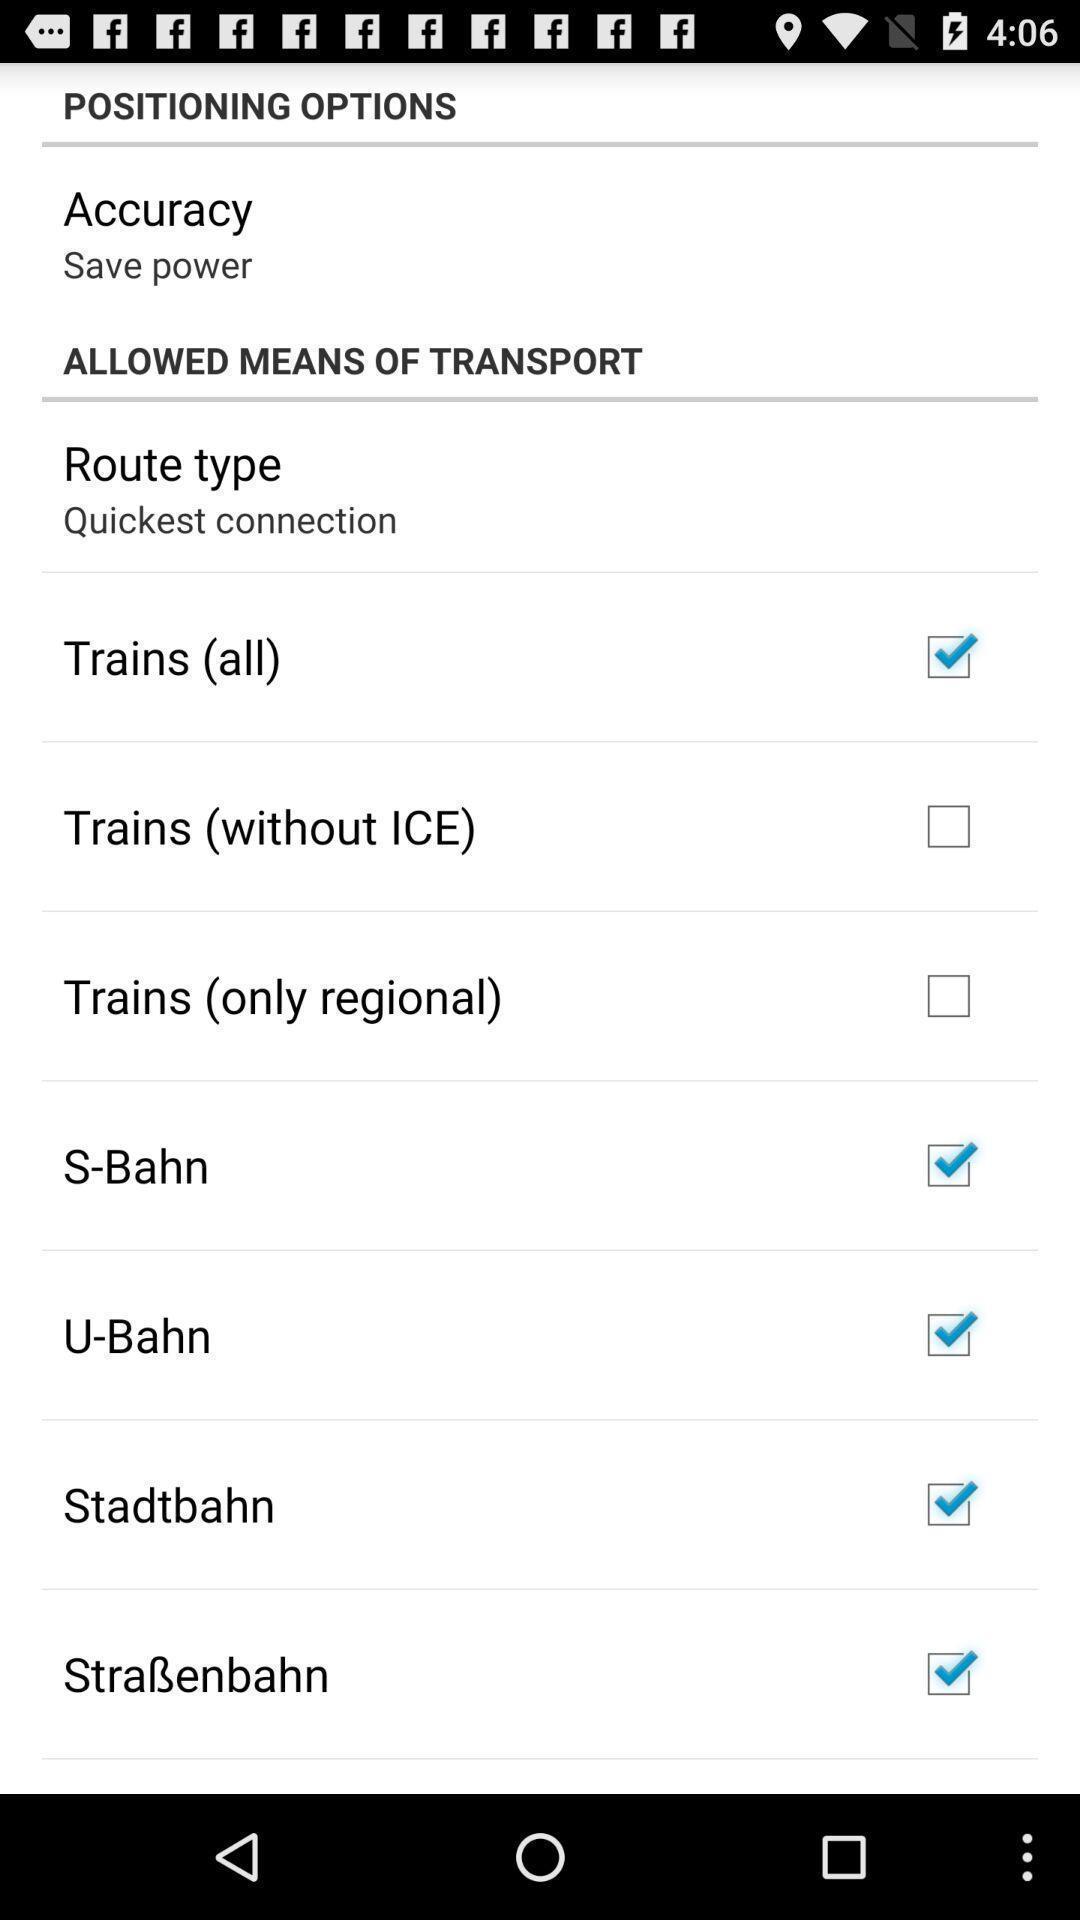Summarize the information in this screenshot. Screen displaying positioning options. 